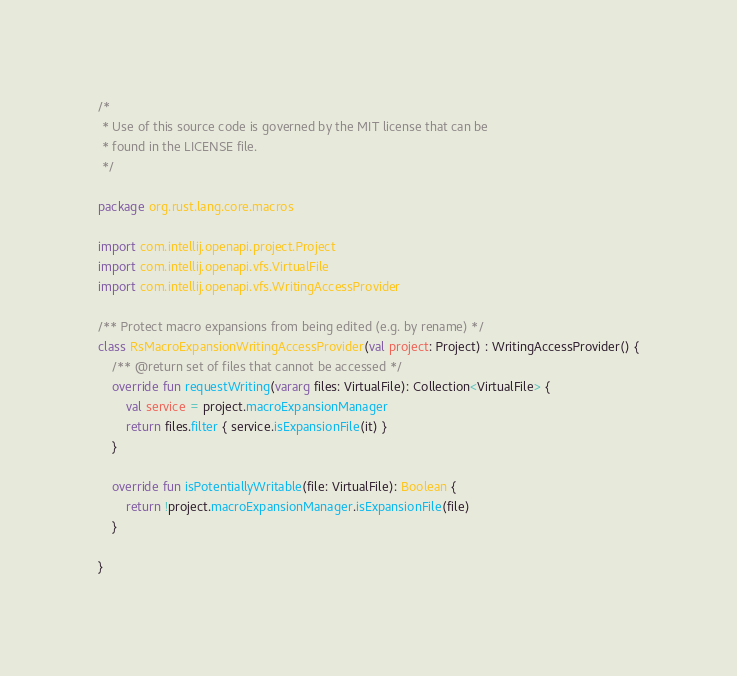<code> <loc_0><loc_0><loc_500><loc_500><_Kotlin_>/*
 * Use of this source code is governed by the MIT license that can be
 * found in the LICENSE file.
 */

package org.rust.lang.core.macros

import com.intellij.openapi.project.Project
import com.intellij.openapi.vfs.VirtualFile
import com.intellij.openapi.vfs.WritingAccessProvider

/** Protect macro expansions from being edited (e.g. by rename) */
class RsMacroExpansionWritingAccessProvider(val project: Project) : WritingAccessProvider() {
    /** @return set of files that cannot be accessed */
    override fun requestWriting(vararg files: VirtualFile): Collection<VirtualFile> {
        val service = project.macroExpansionManager
        return files.filter { service.isExpansionFile(it) }
    }

    override fun isPotentiallyWritable(file: VirtualFile): Boolean {
        return !project.macroExpansionManager.isExpansionFile(file)
    }

}
</code> 